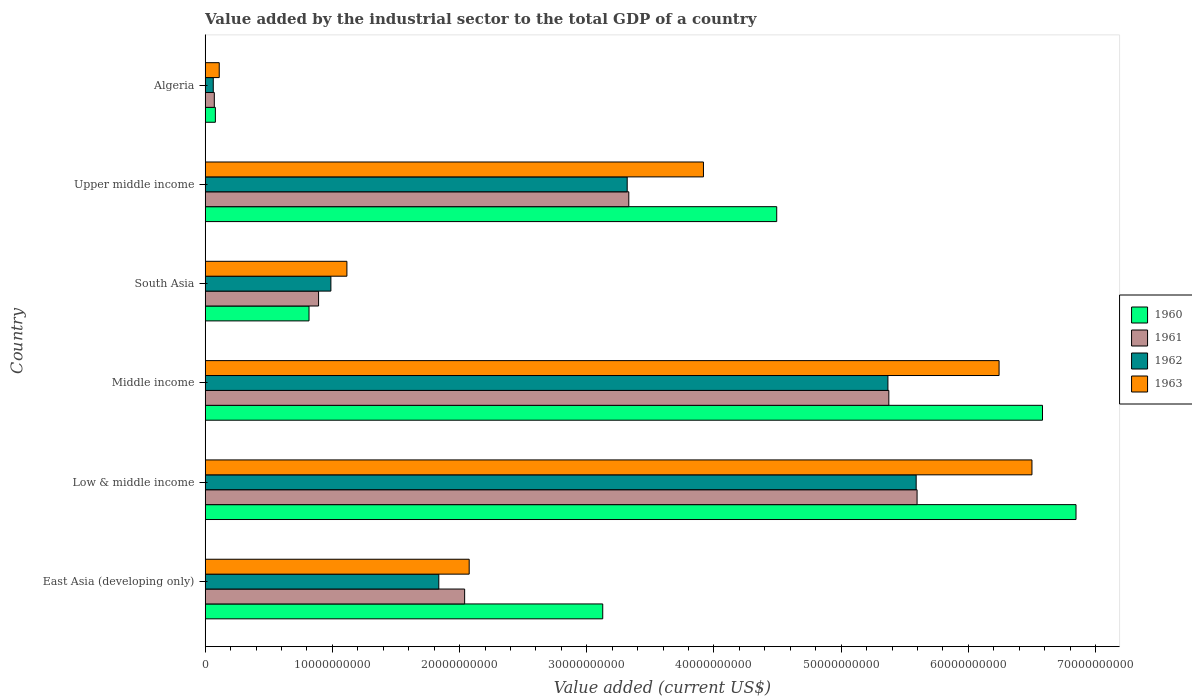How many different coloured bars are there?
Provide a short and direct response. 4. How many groups of bars are there?
Your response must be concise. 6. Are the number of bars on each tick of the Y-axis equal?
Give a very brief answer. Yes. How many bars are there on the 1st tick from the top?
Give a very brief answer. 4. What is the value added by the industrial sector to the total GDP in 1963 in Low & middle income?
Offer a terse response. 6.50e+1. Across all countries, what is the maximum value added by the industrial sector to the total GDP in 1961?
Offer a terse response. 5.60e+1. Across all countries, what is the minimum value added by the industrial sector to the total GDP in 1962?
Keep it short and to the point. 6.34e+08. In which country was the value added by the industrial sector to the total GDP in 1962 minimum?
Your answer should be compact. Algeria. What is the total value added by the industrial sector to the total GDP in 1961 in the graph?
Keep it short and to the point. 1.73e+11. What is the difference between the value added by the industrial sector to the total GDP in 1960 in Middle income and that in Upper middle income?
Your response must be concise. 2.09e+1. What is the difference between the value added by the industrial sector to the total GDP in 1962 in South Asia and the value added by the industrial sector to the total GDP in 1960 in Middle income?
Provide a succinct answer. -5.59e+1. What is the average value added by the industrial sector to the total GDP in 1962 per country?
Offer a terse response. 2.86e+1. What is the difference between the value added by the industrial sector to the total GDP in 1962 and value added by the industrial sector to the total GDP in 1960 in Upper middle income?
Your answer should be compact. -1.18e+1. What is the ratio of the value added by the industrial sector to the total GDP in 1962 in Middle income to that in South Asia?
Make the answer very short. 5.43. Is the value added by the industrial sector to the total GDP in 1960 in South Asia less than that in Upper middle income?
Your response must be concise. Yes. Is the difference between the value added by the industrial sector to the total GDP in 1962 in East Asia (developing only) and Middle income greater than the difference between the value added by the industrial sector to the total GDP in 1960 in East Asia (developing only) and Middle income?
Keep it short and to the point. No. What is the difference between the highest and the second highest value added by the industrial sector to the total GDP in 1961?
Offer a terse response. 2.22e+09. What is the difference between the highest and the lowest value added by the industrial sector to the total GDP in 1963?
Make the answer very short. 6.39e+1. In how many countries, is the value added by the industrial sector to the total GDP in 1962 greater than the average value added by the industrial sector to the total GDP in 1962 taken over all countries?
Make the answer very short. 3. Is the sum of the value added by the industrial sector to the total GDP in 1960 in Low & middle income and South Asia greater than the maximum value added by the industrial sector to the total GDP in 1961 across all countries?
Your answer should be compact. Yes. What does the 3rd bar from the top in Algeria represents?
Your response must be concise. 1961. Is it the case that in every country, the sum of the value added by the industrial sector to the total GDP in 1963 and value added by the industrial sector to the total GDP in 1961 is greater than the value added by the industrial sector to the total GDP in 1962?
Your response must be concise. Yes. Are all the bars in the graph horizontal?
Offer a very short reply. Yes. How many countries are there in the graph?
Give a very brief answer. 6. Are the values on the major ticks of X-axis written in scientific E-notation?
Offer a very short reply. No. How are the legend labels stacked?
Give a very brief answer. Vertical. What is the title of the graph?
Offer a very short reply. Value added by the industrial sector to the total GDP of a country. Does "1975" appear as one of the legend labels in the graph?
Ensure brevity in your answer.  No. What is the label or title of the X-axis?
Give a very brief answer. Value added (current US$). What is the label or title of the Y-axis?
Your answer should be very brief. Country. What is the Value added (current US$) in 1960 in East Asia (developing only)?
Give a very brief answer. 3.13e+1. What is the Value added (current US$) in 1961 in East Asia (developing only)?
Your response must be concise. 2.04e+1. What is the Value added (current US$) of 1962 in East Asia (developing only)?
Ensure brevity in your answer.  1.84e+1. What is the Value added (current US$) of 1963 in East Asia (developing only)?
Ensure brevity in your answer.  2.08e+1. What is the Value added (current US$) of 1960 in Low & middle income?
Provide a succinct answer. 6.85e+1. What is the Value added (current US$) of 1961 in Low & middle income?
Ensure brevity in your answer.  5.60e+1. What is the Value added (current US$) of 1962 in Low & middle income?
Ensure brevity in your answer.  5.59e+1. What is the Value added (current US$) of 1963 in Low & middle income?
Your answer should be compact. 6.50e+1. What is the Value added (current US$) in 1960 in Middle income?
Your answer should be very brief. 6.58e+1. What is the Value added (current US$) of 1961 in Middle income?
Your answer should be very brief. 5.37e+1. What is the Value added (current US$) of 1962 in Middle income?
Provide a short and direct response. 5.37e+1. What is the Value added (current US$) in 1963 in Middle income?
Provide a short and direct response. 6.24e+1. What is the Value added (current US$) of 1960 in South Asia?
Make the answer very short. 8.16e+09. What is the Value added (current US$) in 1961 in South Asia?
Ensure brevity in your answer.  8.91e+09. What is the Value added (current US$) in 1962 in South Asia?
Provide a succinct answer. 9.88e+09. What is the Value added (current US$) in 1963 in South Asia?
Keep it short and to the point. 1.11e+1. What is the Value added (current US$) of 1960 in Upper middle income?
Offer a very short reply. 4.49e+1. What is the Value added (current US$) in 1961 in Upper middle income?
Ensure brevity in your answer.  3.33e+1. What is the Value added (current US$) in 1962 in Upper middle income?
Make the answer very short. 3.32e+1. What is the Value added (current US$) of 1963 in Upper middle income?
Give a very brief answer. 3.92e+1. What is the Value added (current US$) of 1960 in Algeria?
Keep it short and to the point. 8.00e+08. What is the Value added (current US$) of 1961 in Algeria?
Provide a succinct answer. 7.17e+08. What is the Value added (current US$) of 1962 in Algeria?
Give a very brief answer. 6.34e+08. What is the Value added (current US$) of 1963 in Algeria?
Your answer should be compact. 1.10e+09. Across all countries, what is the maximum Value added (current US$) in 1960?
Give a very brief answer. 6.85e+1. Across all countries, what is the maximum Value added (current US$) of 1961?
Give a very brief answer. 5.60e+1. Across all countries, what is the maximum Value added (current US$) of 1962?
Your answer should be very brief. 5.59e+1. Across all countries, what is the maximum Value added (current US$) in 1963?
Provide a short and direct response. 6.50e+1. Across all countries, what is the minimum Value added (current US$) of 1960?
Provide a succinct answer. 8.00e+08. Across all countries, what is the minimum Value added (current US$) in 1961?
Give a very brief answer. 7.17e+08. Across all countries, what is the minimum Value added (current US$) of 1962?
Offer a terse response. 6.34e+08. Across all countries, what is the minimum Value added (current US$) in 1963?
Give a very brief answer. 1.10e+09. What is the total Value added (current US$) of 1960 in the graph?
Provide a short and direct response. 2.19e+11. What is the total Value added (current US$) of 1961 in the graph?
Your answer should be compact. 1.73e+11. What is the total Value added (current US$) in 1962 in the graph?
Give a very brief answer. 1.72e+11. What is the total Value added (current US$) in 1963 in the graph?
Ensure brevity in your answer.  2.00e+11. What is the difference between the Value added (current US$) in 1960 in East Asia (developing only) and that in Low & middle income?
Provide a succinct answer. -3.72e+1. What is the difference between the Value added (current US$) in 1961 in East Asia (developing only) and that in Low & middle income?
Offer a very short reply. -3.56e+1. What is the difference between the Value added (current US$) in 1962 in East Asia (developing only) and that in Low & middle income?
Provide a short and direct response. -3.75e+1. What is the difference between the Value added (current US$) of 1963 in East Asia (developing only) and that in Low & middle income?
Your answer should be compact. -4.42e+1. What is the difference between the Value added (current US$) in 1960 in East Asia (developing only) and that in Middle income?
Offer a terse response. -3.46e+1. What is the difference between the Value added (current US$) of 1961 in East Asia (developing only) and that in Middle income?
Ensure brevity in your answer.  -3.33e+1. What is the difference between the Value added (current US$) in 1962 in East Asia (developing only) and that in Middle income?
Offer a very short reply. -3.53e+1. What is the difference between the Value added (current US$) in 1963 in East Asia (developing only) and that in Middle income?
Give a very brief answer. -4.17e+1. What is the difference between the Value added (current US$) in 1960 in East Asia (developing only) and that in South Asia?
Your answer should be very brief. 2.31e+1. What is the difference between the Value added (current US$) of 1961 in East Asia (developing only) and that in South Asia?
Provide a short and direct response. 1.15e+1. What is the difference between the Value added (current US$) in 1962 in East Asia (developing only) and that in South Asia?
Your answer should be compact. 8.48e+09. What is the difference between the Value added (current US$) in 1963 in East Asia (developing only) and that in South Asia?
Keep it short and to the point. 9.61e+09. What is the difference between the Value added (current US$) in 1960 in East Asia (developing only) and that in Upper middle income?
Give a very brief answer. -1.37e+1. What is the difference between the Value added (current US$) in 1961 in East Asia (developing only) and that in Upper middle income?
Offer a terse response. -1.29e+1. What is the difference between the Value added (current US$) in 1962 in East Asia (developing only) and that in Upper middle income?
Give a very brief answer. -1.48e+1. What is the difference between the Value added (current US$) in 1963 in East Asia (developing only) and that in Upper middle income?
Your response must be concise. -1.84e+1. What is the difference between the Value added (current US$) in 1960 in East Asia (developing only) and that in Algeria?
Provide a succinct answer. 3.05e+1. What is the difference between the Value added (current US$) in 1961 in East Asia (developing only) and that in Algeria?
Offer a very short reply. 1.97e+1. What is the difference between the Value added (current US$) in 1962 in East Asia (developing only) and that in Algeria?
Make the answer very short. 1.77e+1. What is the difference between the Value added (current US$) in 1963 in East Asia (developing only) and that in Algeria?
Keep it short and to the point. 1.97e+1. What is the difference between the Value added (current US$) of 1960 in Low & middle income and that in Middle income?
Offer a terse response. 2.63e+09. What is the difference between the Value added (current US$) in 1961 in Low & middle income and that in Middle income?
Your answer should be compact. 2.22e+09. What is the difference between the Value added (current US$) of 1962 in Low & middle income and that in Middle income?
Make the answer very short. 2.22e+09. What is the difference between the Value added (current US$) of 1963 in Low & middle income and that in Middle income?
Ensure brevity in your answer.  2.59e+09. What is the difference between the Value added (current US$) of 1960 in Low & middle income and that in South Asia?
Offer a very short reply. 6.03e+1. What is the difference between the Value added (current US$) in 1961 in Low & middle income and that in South Asia?
Your answer should be very brief. 4.71e+1. What is the difference between the Value added (current US$) in 1962 in Low & middle income and that in South Asia?
Ensure brevity in your answer.  4.60e+1. What is the difference between the Value added (current US$) of 1963 in Low & middle income and that in South Asia?
Make the answer very short. 5.39e+1. What is the difference between the Value added (current US$) of 1960 in Low & middle income and that in Upper middle income?
Give a very brief answer. 2.35e+1. What is the difference between the Value added (current US$) of 1961 in Low & middle income and that in Upper middle income?
Offer a terse response. 2.27e+1. What is the difference between the Value added (current US$) in 1962 in Low & middle income and that in Upper middle income?
Give a very brief answer. 2.27e+1. What is the difference between the Value added (current US$) in 1963 in Low & middle income and that in Upper middle income?
Ensure brevity in your answer.  2.58e+1. What is the difference between the Value added (current US$) in 1960 in Low & middle income and that in Algeria?
Keep it short and to the point. 6.77e+1. What is the difference between the Value added (current US$) in 1961 in Low & middle income and that in Algeria?
Provide a succinct answer. 5.53e+1. What is the difference between the Value added (current US$) of 1962 in Low & middle income and that in Algeria?
Ensure brevity in your answer.  5.53e+1. What is the difference between the Value added (current US$) of 1963 in Low & middle income and that in Algeria?
Give a very brief answer. 6.39e+1. What is the difference between the Value added (current US$) of 1960 in Middle income and that in South Asia?
Keep it short and to the point. 5.77e+1. What is the difference between the Value added (current US$) of 1961 in Middle income and that in South Asia?
Provide a short and direct response. 4.48e+1. What is the difference between the Value added (current US$) in 1962 in Middle income and that in South Asia?
Offer a terse response. 4.38e+1. What is the difference between the Value added (current US$) of 1963 in Middle income and that in South Asia?
Ensure brevity in your answer.  5.13e+1. What is the difference between the Value added (current US$) of 1960 in Middle income and that in Upper middle income?
Keep it short and to the point. 2.09e+1. What is the difference between the Value added (current US$) of 1961 in Middle income and that in Upper middle income?
Offer a terse response. 2.04e+1. What is the difference between the Value added (current US$) of 1962 in Middle income and that in Upper middle income?
Offer a very short reply. 2.05e+1. What is the difference between the Value added (current US$) in 1963 in Middle income and that in Upper middle income?
Offer a very short reply. 2.32e+1. What is the difference between the Value added (current US$) in 1960 in Middle income and that in Algeria?
Your answer should be very brief. 6.50e+1. What is the difference between the Value added (current US$) of 1961 in Middle income and that in Algeria?
Keep it short and to the point. 5.30e+1. What is the difference between the Value added (current US$) in 1962 in Middle income and that in Algeria?
Provide a short and direct response. 5.30e+1. What is the difference between the Value added (current US$) of 1963 in Middle income and that in Algeria?
Your answer should be very brief. 6.13e+1. What is the difference between the Value added (current US$) of 1960 in South Asia and that in Upper middle income?
Offer a terse response. -3.68e+1. What is the difference between the Value added (current US$) in 1961 in South Asia and that in Upper middle income?
Make the answer very short. -2.44e+1. What is the difference between the Value added (current US$) of 1962 in South Asia and that in Upper middle income?
Ensure brevity in your answer.  -2.33e+1. What is the difference between the Value added (current US$) of 1963 in South Asia and that in Upper middle income?
Your response must be concise. -2.80e+1. What is the difference between the Value added (current US$) of 1960 in South Asia and that in Algeria?
Your response must be concise. 7.36e+09. What is the difference between the Value added (current US$) in 1961 in South Asia and that in Algeria?
Keep it short and to the point. 8.20e+09. What is the difference between the Value added (current US$) in 1962 in South Asia and that in Algeria?
Keep it short and to the point. 9.25e+09. What is the difference between the Value added (current US$) in 1963 in South Asia and that in Algeria?
Make the answer very short. 1.00e+1. What is the difference between the Value added (current US$) in 1960 in Upper middle income and that in Algeria?
Offer a terse response. 4.41e+1. What is the difference between the Value added (current US$) in 1961 in Upper middle income and that in Algeria?
Give a very brief answer. 3.26e+1. What is the difference between the Value added (current US$) of 1962 in Upper middle income and that in Algeria?
Provide a short and direct response. 3.25e+1. What is the difference between the Value added (current US$) of 1963 in Upper middle income and that in Algeria?
Offer a very short reply. 3.81e+1. What is the difference between the Value added (current US$) in 1960 in East Asia (developing only) and the Value added (current US$) in 1961 in Low & middle income?
Offer a very short reply. -2.47e+1. What is the difference between the Value added (current US$) in 1960 in East Asia (developing only) and the Value added (current US$) in 1962 in Low & middle income?
Ensure brevity in your answer.  -2.46e+1. What is the difference between the Value added (current US$) of 1960 in East Asia (developing only) and the Value added (current US$) of 1963 in Low & middle income?
Keep it short and to the point. -3.37e+1. What is the difference between the Value added (current US$) in 1961 in East Asia (developing only) and the Value added (current US$) in 1962 in Low & middle income?
Offer a terse response. -3.55e+1. What is the difference between the Value added (current US$) in 1961 in East Asia (developing only) and the Value added (current US$) in 1963 in Low & middle income?
Offer a terse response. -4.46e+1. What is the difference between the Value added (current US$) of 1962 in East Asia (developing only) and the Value added (current US$) of 1963 in Low & middle income?
Offer a very short reply. -4.66e+1. What is the difference between the Value added (current US$) of 1960 in East Asia (developing only) and the Value added (current US$) of 1961 in Middle income?
Ensure brevity in your answer.  -2.25e+1. What is the difference between the Value added (current US$) of 1960 in East Asia (developing only) and the Value added (current US$) of 1962 in Middle income?
Your answer should be very brief. -2.24e+1. What is the difference between the Value added (current US$) of 1960 in East Asia (developing only) and the Value added (current US$) of 1963 in Middle income?
Ensure brevity in your answer.  -3.12e+1. What is the difference between the Value added (current US$) in 1961 in East Asia (developing only) and the Value added (current US$) in 1962 in Middle income?
Offer a very short reply. -3.33e+1. What is the difference between the Value added (current US$) in 1961 in East Asia (developing only) and the Value added (current US$) in 1963 in Middle income?
Give a very brief answer. -4.20e+1. What is the difference between the Value added (current US$) of 1962 in East Asia (developing only) and the Value added (current US$) of 1963 in Middle income?
Offer a terse response. -4.41e+1. What is the difference between the Value added (current US$) in 1960 in East Asia (developing only) and the Value added (current US$) in 1961 in South Asia?
Offer a very short reply. 2.23e+1. What is the difference between the Value added (current US$) of 1960 in East Asia (developing only) and the Value added (current US$) of 1962 in South Asia?
Give a very brief answer. 2.14e+1. What is the difference between the Value added (current US$) of 1960 in East Asia (developing only) and the Value added (current US$) of 1963 in South Asia?
Your response must be concise. 2.01e+1. What is the difference between the Value added (current US$) in 1961 in East Asia (developing only) and the Value added (current US$) in 1962 in South Asia?
Keep it short and to the point. 1.05e+1. What is the difference between the Value added (current US$) in 1961 in East Asia (developing only) and the Value added (current US$) in 1963 in South Asia?
Provide a succinct answer. 9.26e+09. What is the difference between the Value added (current US$) of 1962 in East Asia (developing only) and the Value added (current US$) of 1963 in South Asia?
Offer a very short reply. 7.22e+09. What is the difference between the Value added (current US$) in 1960 in East Asia (developing only) and the Value added (current US$) in 1961 in Upper middle income?
Make the answer very short. -2.05e+09. What is the difference between the Value added (current US$) in 1960 in East Asia (developing only) and the Value added (current US$) in 1962 in Upper middle income?
Give a very brief answer. -1.92e+09. What is the difference between the Value added (current US$) in 1960 in East Asia (developing only) and the Value added (current US$) in 1963 in Upper middle income?
Provide a short and direct response. -7.92e+09. What is the difference between the Value added (current US$) in 1961 in East Asia (developing only) and the Value added (current US$) in 1962 in Upper middle income?
Provide a succinct answer. -1.28e+1. What is the difference between the Value added (current US$) of 1961 in East Asia (developing only) and the Value added (current US$) of 1963 in Upper middle income?
Offer a terse response. -1.88e+1. What is the difference between the Value added (current US$) in 1962 in East Asia (developing only) and the Value added (current US$) in 1963 in Upper middle income?
Provide a succinct answer. -2.08e+1. What is the difference between the Value added (current US$) of 1960 in East Asia (developing only) and the Value added (current US$) of 1961 in Algeria?
Provide a succinct answer. 3.05e+1. What is the difference between the Value added (current US$) of 1960 in East Asia (developing only) and the Value added (current US$) of 1962 in Algeria?
Offer a terse response. 3.06e+1. What is the difference between the Value added (current US$) of 1960 in East Asia (developing only) and the Value added (current US$) of 1963 in Algeria?
Offer a very short reply. 3.02e+1. What is the difference between the Value added (current US$) in 1961 in East Asia (developing only) and the Value added (current US$) in 1962 in Algeria?
Keep it short and to the point. 1.98e+1. What is the difference between the Value added (current US$) of 1961 in East Asia (developing only) and the Value added (current US$) of 1963 in Algeria?
Give a very brief answer. 1.93e+1. What is the difference between the Value added (current US$) in 1962 in East Asia (developing only) and the Value added (current US$) in 1963 in Algeria?
Offer a terse response. 1.73e+1. What is the difference between the Value added (current US$) of 1960 in Low & middle income and the Value added (current US$) of 1961 in Middle income?
Keep it short and to the point. 1.47e+1. What is the difference between the Value added (current US$) in 1960 in Low & middle income and the Value added (current US$) in 1962 in Middle income?
Offer a terse response. 1.48e+1. What is the difference between the Value added (current US$) of 1960 in Low & middle income and the Value added (current US$) of 1963 in Middle income?
Provide a succinct answer. 6.05e+09. What is the difference between the Value added (current US$) in 1961 in Low & middle income and the Value added (current US$) in 1962 in Middle income?
Ensure brevity in your answer.  2.29e+09. What is the difference between the Value added (current US$) in 1961 in Low & middle income and the Value added (current US$) in 1963 in Middle income?
Provide a short and direct response. -6.45e+09. What is the difference between the Value added (current US$) in 1962 in Low & middle income and the Value added (current US$) in 1963 in Middle income?
Give a very brief answer. -6.52e+09. What is the difference between the Value added (current US$) of 1960 in Low & middle income and the Value added (current US$) of 1961 in South Asia?
Make the answer very short. 5.96e+1. What is the difference between the Value added (current US$) in 1960 in Low & middle income and the Value added (current US$) in 1962 in South Asia?
Provide a succinct answer. 5.86e+1. What is the difference between the Value added (current US$) of 1960 in Low & middle income and the Value added (current US$) of 1963 in South Asia?
Give a very brief answer. 5.73e+1. What is the difference between the Value added (current US$) of 1961 in Low & middle income and the Value added (current US$) of 1962 in South Asia?
Offer a very short reply. 4.61e+1. What is the difference between the Value added (current US$) in 1961 in Low & middle income and the Value added (current US$) in 1963 in South Asia?
Your response must be concise. 4.48e+1. What is the difference between the Value added (current US$) of 1962 in Low & middle income and the Value added (current US$) of 1963 in South Asia?
Give a very brief answer. 4.48e+1. What is the difference between the Value added (current US$) in 1960 in Low & middle income and the Value added (current US$) in 1961 in Upper middle income?
Offer a terse response. 3.52e+1. What is the difference between the Value added (current US$) of 1960 in Low & middle income and the Value added (current US$) of 1962 in Upper middle income?
Keep it short and to the point. 3.53e+1. What is the difference between the Value added (current US$) of 1960 in Low & middle income and the Value added (current US$) of 1963 in Upper middle income?
Your response must be concise. 2.93e+1. What is the difference between the Value added (current US$) of 1961 in Low & middle income and the Value added (current US$) of 1962 in Upper middle income?
Provide a succinct answer. 2.28e+1. What is the difference between the Value added (current US$) of 1961 in Low & middle income and the Value added (current US$) of 1963 in Upper middle income?
Offer a very short reply. 1.68e+1. What is the difference between the Value added (current US$) in 1962 in Low & middle income and the Value added (current US$) in 1963 in Upper middle income?
Provide a succinct answer. 1.67e+1. What is the difference between the Value added (current US$) in 1960 in Low & middle income and the Value added (current US$) in 1961 in Algeria?
Keep it short and to the point. 6.77e+1. What is the difference between the Value added (current US$) of 1960 in Low & middle income and the Value added (current US$) of 1962 in Algeria?
Provide a short and direct response. 6.78e+1. What is the difference between the Value added (current US$) of 1960 in Low & middle income and the Value added (current US$) of 1963 in Algeria?
Offer a very short reply. 6.74e+1. What is the difference between the Value added (current US$) in 1961 in Low & middle income and the Value added (current US$) in 1962 in Algeria?
Make the answer very short. 5.53e+1. What is the difference between the Value added (current US$) in 1961 in Low & middle income and the Value added (current US$) in 1963 in Algeria?
Give a very brief answer. 5.49e+1. What is the difference between the Value added (current US$) of 1962 in Low & middle income and the Value added (current US$) of 1963 in Algeria?
Provide a succinct answer. 5.48e+1. What is the difference between the Value added (current US$) in 1960 in Middle income and the Value added (current US$) in 1961 in South Asia?
Offer a very short reply. 5.69e+1. What is the difference between the Value added (current US$) of 1960 in Middle income and the Value added (current US$) of 1962 in South Asia?
Your answer should be very brief. 5.59e+1. What is the difference between the Value added (current US$) in 1960 in Middle income and the Value added (current US$) in 1963 in South Asia?
Offer a terse response. 5.47e+1. What is the difference between the Value added (current US$) of 1961 in Middle income and the Value added (current US$) of 1962 in South Asia?
Offer a very short reply. 4.39e+1. What is the difference between the Value added (current US$) in 1961 in Middle income and the Value added (current US$) in 1963 in South Asia?
Offer a terse response. 4.26e+1. What is the difference between the Value added (current US$) in 1962 in Middle income and the Value added (current US$) in 1963 in South Asia?
Your answer should be very brief. 4.25e+1. What is the difference between the Value added (current US$) of 1960 in Middle income and the Value added (current US$) of 1961 in Upper middle income?
Offer a very short reply. 3.25e+1. What is the difference between the Value added (current US$) of 1960 in Middle income and the Value added (current US$) of 1962 in Upper middle income?
Your response must be concise. 3.27e+1. What is the difference between the Value added (current US$) in 1960 in Middle income and the Value added (current US$) in 1963 in Upper middle income?
Your response must be concise. 2.67e+1. What is the difference between the Value added (current US$) of 1961 in Middle income and the Value added (current US$) of 1962 in Upper middle income?
Keep it short and to the point. 2.06e+1. What is the difference between the Value added (current US$) in 1961 in Middle income and the Value added (current US$) in 1963 in Upper middle income?
Ensure brevity in your answer.  1.46e+1. What is the difference between the Value added (current US$) in 1962 in Middle income and the Value added (current US$) in 1963 in Upper middle income?
Your answer should be very brief. 1.45e+1. What is the difference between the Value added (current US$) of 1960 in Middle income and the Value added (current US$) of 1961 in Algeria?
Your answer should be very brief. 6.51e+1. What is the difference between the Value added (current US$) of 1960 in Middle income and the Value added (current US$) of 1962 in Algeria?
Give a very brief answer. 6.52e+1. What is the difference between the Value added (current US$) of 1960 in Middle income and the Value added (current US$) of 1963 in Algeria?
Give a very brief answer. 6.47e+1. What is the difference between the Value added (current US$) of 1961 in Middle income and the Value added (current US$) of 1962 in Algeria?
Your answer should be very brief. 5.31e+1. What is the difference between the Value added (current US$) of 1961 in Middle income and the Value added (current US$) of 1963 in Algeria?
Provide a succinct answer. 5.26e+1. What is the difference between the Value added (current US$) in 1962 in Middle income and the Value added (current US$) in 1963 in Algeria?
Your answer should be compact. 5.26e+1. What is the difference between the Value added (current US$) in 1960 in South Asia and the Value added (current US$) in 1961 in Upper middle income?
Make the answer very short. -2.51e+1. What is the difference between the Value added (current US$) in 1960 in South Asia and the Value added (current US$) in 1962 in Upper middle income?
Offer a very short reply. -2.50e+1. What is the difference between the Value added (current US$) of 1960 in South Asia and the Value added (current US$) of 1963 in Upper middle income?
Your response must be concise. -3.10e+1. What is the difference between the Value added (current US$) of 1961 in South Asia and the Value added (current US$) of 1962 in Upper middle income?
Your response must be concise. -2.43e+1. What is the difference between the Value added (current US$) of 1961 in South Asia and the Value added (current US$) of 1963 in Upper middle income?
Give a very brief answer. -3.03e+1. What is the difference between the Value added (current US$) in 1962 in South Asia and the Value added (current US$) in 1963 in Upper middle income?
Your answer should be compact. -2.93e+1. What is the difference between the Value added (current US$) in 1960 in South Asia and the Value added (current US$) in 1961 in Algeria?
Your answer should be compact. 7.44e+09. What is the difference between the Value added (current US$) of 1960 in South Asia and the Value added (current US$) of 1962 in Algeria?
Offer a very short reply. 7.53e+09. What is the difference between the Value added (current US$) in 1960 in South Asia and the Value added (current US$) in 1963 in Algeria?
Provide a succinct answer. 7.06e+09. What is the difference between the Value added (current US$) of 1961 in South Asia and the Value added (current US$) of 1962 in Algeria?
Give a very brief answer. 8.28e+09. What is the difference between the Value added (current US$) of 1961 in South Asia and the Value added (current US$) of 1963 in Algeria?
Keep it short and to the point. 7.81e+09. What is the difference between the Value added (current US$) of 1962 in South Asia and the Value added (current US$) of 1963 in Algeria?
Make the answer very short. 8.78e+09. What is the difference between the Value added (current US$) in 1960 in Upper middle income and the Value added (current US$) in 1961 in Algeria?
Offer a terse response. 4.42e+1. What is the difference between the Value added (current US$) in 1960 in Upper middle income and the Value added (current US$) in 1962 in Algeria?
Your answer should be compact. 4.43e+1. What is the difference between the Value added (current US$) in 1960 in Upper middle income and the Value added (current US$) in 1963 in Algeria?
Provide a succinct answer. 4.38e+1. What is the difference between the Value added (current US$) in 1961 in Upper middle income and the Value added (current US$) in 1962 in Algeria?
Offer a terse response. 3.27e+1. What is the difference between the Value added (current US$) in 1961 in Upper middle income and the Value added (current US$) in 1963 in Algeria?
Your answer should be compact. 3.22e+1. What is the difference between the Value added (current US$) of 1962 in Upper middle income and the Value added (current US$) of 1963 in Algeria?
Your response must be concise. 3.21e+1. What is the average Value added (current US$) in 1960 per country?
Offer a very short reply. 3.66e+1. What is the average Value added (current US$) of 1961 per country?
Your answer should be compact. 2.88e+1. What is the average Value added (current US$) in 1962 per country?
Make the answer very short. 2.86e+1. What is the average Value added (current US$) in 1963 per country?
Give a very brief answer. 3.33e+1. What is the difference between the Value added (current US$) of 1960 and Value added (current US$) of 1961 in East Asia (developing only)?
Offer a very short reply. 1.09e+1. What is the difference between the Value added (current US$) in 1960 and Value added (current US$) in 1962 in East Asia (developing only)?
Ensure brevity in your answer.  1.29e+1. What is the difference between the Value added (current US$) of 1960 and Value added (current US$) of 1963 in East Asia (developing only)?
Keep it short and to the point. 1.05e+1. What is the difference between the Value added (current US$) in 1961 and Value added (current US$) in 1962 in East Asia (developing only)?
Your answer should be compact. 2.03e+09. What is the difference between the Value added (current US$) in 1961 and Value added (current US$) in 1963 in East Asia (developing only)?
Ensure brevity in your answer.  -3.57e+08. What is the difference between the Value added (current US$) in 1962 and Value added (current US$) in 1963 in East Asia (developing only)?
Keep it short and to the point. -2.39e+09. What is the difference between the Value added (current US$) of 1960 and Value added (current US$) of 1961 in Low & middle income?
Offer a terse response. 1.25e+1. What is the difference between the Value added (current US$) in 1960 and Value added (current US$) in 1962 in Low & middle income?
Give a very brief answer. 1.26e+1. What is the difference between the Value added (current US$) in 1960 and Value added (current US$) in 1963 in Low & middle income?
Make the answer very short. 3.46e+09. What is the difference between the Value added (current US$) in 1961 and Value added (current US$) in 1962 in Low & middle income?
Your answer should be very brief. 7.11e+07. What is the difference between the Value added (current US$) in 1961 and Value added (current US$) in 1963 in Low & middle income?
Offer a very short reply. -9.03e+09. What is the difference between the Value added (current US$) in 1962 and Value added (current US$) in 1963 in Low & middle income?
Your response must be concise. -9.10e+09. What is the difference between the Value added (current US$) of 1960 and Value added (current US$) of 1961 in Middle income?
Provide a succinct answer. 1.21e+1. What is the difference between the Value added (current US$) in 1960 and Value added (current US$) in 1962 in Middle income?
Ensure brevity in your answer.  1.22e+1. What is the difference between the Value added (current US$) of 1960 and Value added (current US$) of 1963 in Middle income?
Your response must be concise. 3.41e+09. What is the difference between the Value added (current US$) of 1961 and Value added (current US$) of 1962 in Middle income?
Your answer should be compact. 7.12e+07. What is the difference between the Value added (current US$) of 1961 and Value added (current US$) of 1963 in Middle income?
Keep it short and to the point. -8.67e+09. What is the difference between the Value added (current US$) of 1962 and Value added (current US$) of 1963 in Middle income?
Offer a terse response. -8.74e+09. What is the difference between the Value added (current US$) in 1960 and Value added (current US$) in 1961 in South Asia?
Your response must be concise. -7.53e+08. What is the difference between the Value added (current US$) in 1960 and Value added (current US$) in 1962 in South Asia?
Keep it short and to the point. -1.72e+09. What is the difference between the Value added (current US$) of 1960 and Value added (current US$) of 1963 in South Asia?
Give a very brief answer. -2.98e+09. What is the difference between the Value added (current US$) in 1961 and Value added (current US$) in 1962 in South Asia?
Keep it short and to the point. -9.68e+08. What is the difference between the Value added (current US$) in 1961 and Value added (current US$) in 1963 in South Asia?
Offer a very short reply. -2.23e+09. What is the difference between the Value added (current US$) in 1962 and Value added (current US$) in 1963 in South Asia?
Your answer should be compact. -1.26e+09. What is the difference between the Value added (current US$) in 1960 and Value added (current US$) in 1961 in Upper middle income?
Your answer should be very brief. 1.16e+1. What is the difference between the Value added (current US$) in 1960 and Value added (current US$) in 1962 in Upper middle income?
Your answer should be compact. 1.18e+1. What is the difference between the Value added (current US$) in 1960 and Value added (current US$) in 1963 in Upper middle income?
Provide a short and direct response. 5.76e+09. What is the difference between the Value added (current US$) of 1961 and Value added (current US$) of 1962 in Upper middle income?
Provide a succinct answer. 1.26e+08. What is the difference between the Value added (current US$) of 1961 and Value added (current US$) of 1963 in Upper middle income?
Make the answer very short. -5.87e+09. What is the difference between the Value added (current US$) in 1962 and Value added (current US$) in 1963 in Upper middle income?
Provide a short and direct response. -5.99e+09. What is the difference between the Value added (current US$) in 1960 and Value added (current US$) in 1961 in Algeria?
Your answer should be compact. 8.27e+07. What is the difference between the Value added (current US$) in 1960 and Value added (current US$) in 1962 in Algeria?
Provide a succinct answer. 1.65e+08. What is the difference between the Value added (current US$) of 1960 and Value added (current US$) of 1963 in Algeria?
Offer a very short reply. -3.03e+08. What is the difference between the Value added (current US$) of 1961 and Value added (current US$) of 1962 in Algeria?
Provide a short and direct response. 8.27e+07. What is the difference between the Value added (current US$) in 1961 and Value added (current US$) in 1963 in Algeria?
Your answer should be very brief. -3.86e+08. What is the difference between the Value added (current US$) of 1962 and Value added (current US$) of 1963 in Algeria?
Provide a succinct answer. -4.69e+08. What is the ratio of the Value added (current US$) of 1960 in East Asia (developing only) to that in Low & middle income?
Offer a very short reply. 0.46. What is the ratio of the Value added (current US$) in 1961 in East Asia (developing only) to that in Low & middle income?
Provide a succinct answer. 0.36. What is the ratio of the Value added (current US$) in 1962 in East Asia (developing only) to that in Low & middle income?
Provide a short and direct response. 0.33. What is the ratio of the Value added (current US$) in 1963 in East Asia (developing only) to that in Low & middle income?
Your answer should be compact. 0.32. What is the ratio of the Value added (current US$) in 1960 in East Asia (developing only) to that in Middle income?
Provide a succinct answer. 0.47. What is the ratio of the Value added (current US$) of 1961 in East Asia (developing only) to that in Middle income?
Your answer should be compact. 0.38. What is the ratio of the Value added (current US$) in 1962 in East Asia (developing only) to that in Middle income?
Your answer should be very brief. 0.34. What is the ratio of the Value added (current US$) in 1963 in East Asia (developing only) to that in Middle income?
Provide a short and direct response. 0.33. What is the ratio of the Value added (current US$) in 1960 in East Asia (developing only) to that in South Asia?
Your response must be concise. 3.83. What is the ratio of the Value added (current US$) in 1961 in East Asia (developing only) to that in South Asia?
Give a very brief answer. 2.29. What is the ratio of the Value added (current US$) in 1962 in East Asia (developing only) to that in South Asia?
Offer a terse response. 1.86. What is the ratio of the Value added (current US$) in 1963 in East Asia (developing only) to that in South Asia?
Give a very brief answer. 1.86. What is the ratio of the Value added (current US$) in 1960 in East Asia (developing only) to that in Upper middle income?
Keep it short and to the point. 0.7. What is the ratio of the Value added (current US$) of 1961 in East Asia (developing only) to that in Upper middle income?
Your answer should be very brief. 0.61. What is the ratio of the Value added (current US$) in 1962 in East Asia (developing only) to that in Upper middle income?
Provide a succinct answer. 0.55. What is the ratio of the Value added (current US$) of 1963 in East Asia (developing only) to that in Upper middle income?
Offer a terse response. 0.53. What is the ratio of the Value added (current US$) in 1960 in East Asia (developing only) to that in Algeria?
Provide a short and direct response. 39.07. What is the ratio of the Value added (current US$) in 1961 in East Asia (developing only) to that in Algeria?
Keep it short and to the point. 28.44. What is the ratio of the Value added (current US$) of 1962 in East Asia (developing only) to that in Algeria?
Your answer should be compact. 28.95. What is the ratio of the Value added (current US$) in 1963 in East Asia (developing only) to that in Algeria?
Keep it short and to the point. 18.81. What is the ratio of the Value added (current US$) of 1961 in Low & middle income to that in Middle income?
Offer a very short reply. 1.04. What is the ratio of the Value added (current US$) of 1962 in Low & middle income to that in Middle income?
Offer a terse response. 1.04. What is the ratio of the Value added (current US$) of 1963 in Low & middle income to that in Middle income?
Give a very brief answer. 1.04. What is the ratio of the Value added (current US$) of 1960 in Low & middle income to that in South Asia?
Give a very brief answer. 8.39. What is the ratio of the Value added (current US$) of 1961 in Low & middle income to that in South Asia?
Offer a terse response. 6.28. What is the ratio of the Value added (current US$) of 1962 in Low & middle income to that in South Asia?
Ensure brevity in your answer.  5.66. What is the ratio of the Value added (current US$) of 1963 in Low & middle income to that in South Asia?
Make the answer very short. 5.83. What is the ratio of the Value added (current US$) of 1960 in Low & middle income to that in Upper middle income?
Ensure brevity in your answer.  1.52. What is the ratio of the Value added (current US$) in 1961 in Low & middle income to that in Upper middle income?
Provide a short and direct response. 1.68. What is the ratio of the Value added (current US$) of 1962 in Low & middle income to that in Upper middle income?
Ensure brevity in your answer.  1.68. What is the ratio of the Value added (current US$) in 1963 in Low & middle income to that in Upper middle income?
Make the answer very short. 1.66. What is the ratio of the Value added (current US$) of 1960 in Low & middle income to that in Algeria?
Your answer should be compact. 85.59. What is the ratio of the Value added (current US$) in 1961 in Low & middle income to that in Algeria?
Your response must be concise. 78.04. What is the ratio of the Value added (current US$) in 1962 in Low & middle income to that in Algeria?
Your answer should be compact. 88.11. What is the ratio of the Value added (current US$) of 1963 in Low & middle income to that in Algeria?
Give a very brief answer. 58.91. What is the ratio of the Value added (current US$) in 1960 in Middle income to that in South Asia?
Your answer should be very brief. 8.07. What is the ratio of the Value added (current US$) of 1961 in Middle income to that in South Asia?
Provide a short and direct response. 6.03. What is the ratio of the Value added (current US$) of 1962 in Middle income to that in South Asia?
Your answer should be very brief. 5.43. What is the ratio of the Value added (current US$) in 1963 in Middle income to that in South Asia?
Ensure brevity in your answer.  5.6. What is the ratio of the Value added (current US$) in 1960 in Middle income to that in Upper middle income?
Offer a terse response. 1.47. What is the ratio of the Value added (current US$) of 1961 in Middle income to that in Upper middle income?
Keep it short and to the point. 1.61. What is the ratio of the Value added (current US$) in 1962 in Middle income to that in Upper middle income?
Give a very brief answer. 1.62. What is the ratio of the Value added (current US$) in 1963 in Middle income to that in Upper middle income?
Provide a succinct answer. 1.59. What is the ratio of the Value added (current US$) of 1960 in Middle income to that in Algeria?
Provide a short and direct response. 82.3. What is the ratio of the Value added (current US$) in 1961 in Middle income to that in Algeria?
Your answer should be very brief. 74.95. What is the ratio of the Value added (current US$) in 1962 in Middle income to that in Algeria?
Provide a short and direct response. 84.61. What is the ratio of the Value added (current US$) of 1963 in Middle income to that in Algeria?
Offer a terse response. 56.57. What is the ratio of the Value added (current US$) in 1960 in South Asia to that in Upper middle income?
Provide a succinct answer. 0.18. What is the ratio of the Value added (current US$) of 1961 in South Asia to that in Upper middle income?
Your answer should be very brief. 0.27. What is the ratio of the Value added (current US$) in 1962 in South Asia to that in Upper middle income?
Provide a short and direct response. 0.3. What is the ratio of the Value added (current US$) of 1963 in South Asia to that in Upper middle income?
Offer a very short reply. 0.28. What is the ratio of the Value added (current US$) of 1960 in South Asia to that in Algeria?
Keep it short and to the point. 10.2. What is the ratio of the Value added (current US$) of 1961 in South Asia to that in Algeria?
Your response must be concise. 12.43. What is the ratio of the Value added (current US$) in 1962 in South Asia to that in Algeria?
Ensure brevity in your answer.  15.58. What is the ratio of the Value added (current US$) in 1963 in South Asia to that in Algeria?
Make the answer very short. 10.1. What is the ratio of the Value added (current US$) of 1960 in Upper middle income to that in Algeria?
Make the answer very short. 56.17. What is the ratio of the Value added (current US$) of 1961 in Upper middle income to that in Algeria?
Your response must be concise. 46.44. What is the ratio of the Value added (current US$) in 1962 in Upper middle income to that in Algeria?
Keep it short and to the point. 52.3. What is the ratio of the Value added (current US$) of 1963 in Upper middle income to that in Algeria?
Your answer should be compact. 35.5. What is the difference between the highest and the second highest Value added (current US$) in 1960?
Provide a succinct answer. 2.63e+09. What is the difference between the highest and the second highest Value added (current US$) of 1961?
Provide a short and direct response. 2.22e+09. What is the difference between the highest and the second highest Value added (current US$) of 1962?
Provide a short and direct response. 2.22e+09. What is the difference between the highest and the second highest Value added (current US$) in 1963?
Keep it short and to the point. 2.59e+09. What is the difference between the highest and the lowest Value added (current US$) in 1960?
Offer a very short reply. 6.77e+1. What is the difference between the highest and the lowest Value added (current US$) in 1961?
Offer a terse response. 5.53e+1. What is the difference between the highest and the lowest Value added (current US$) of 1962?
Offer a terse response. 5.53e+1. What is the difference between the highest and the lowest Value added (current US$) in 1963?
Ensure brevity in your answer.  6.39e+1. 